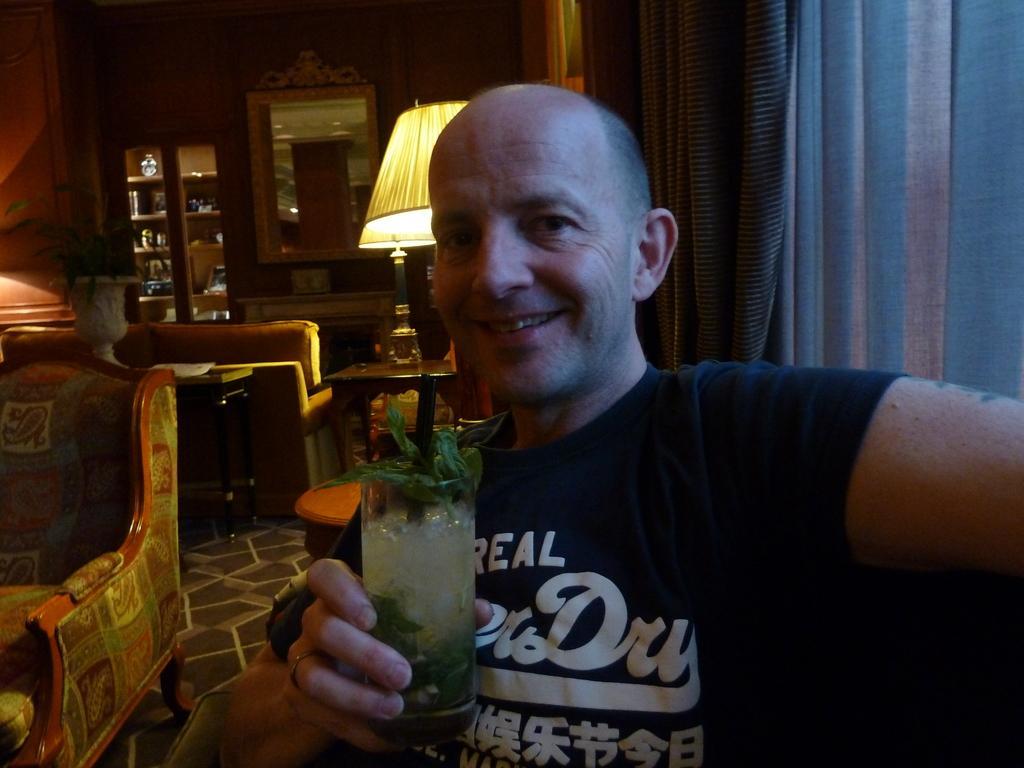Could you give a brief overview of what you see in this image? This image consist of a man wearing a blue t-shirt and holding a glass in his hand. To the right, there is a window and curtain. In the background, there are cupboards, furniture, sofas, and mirror. 